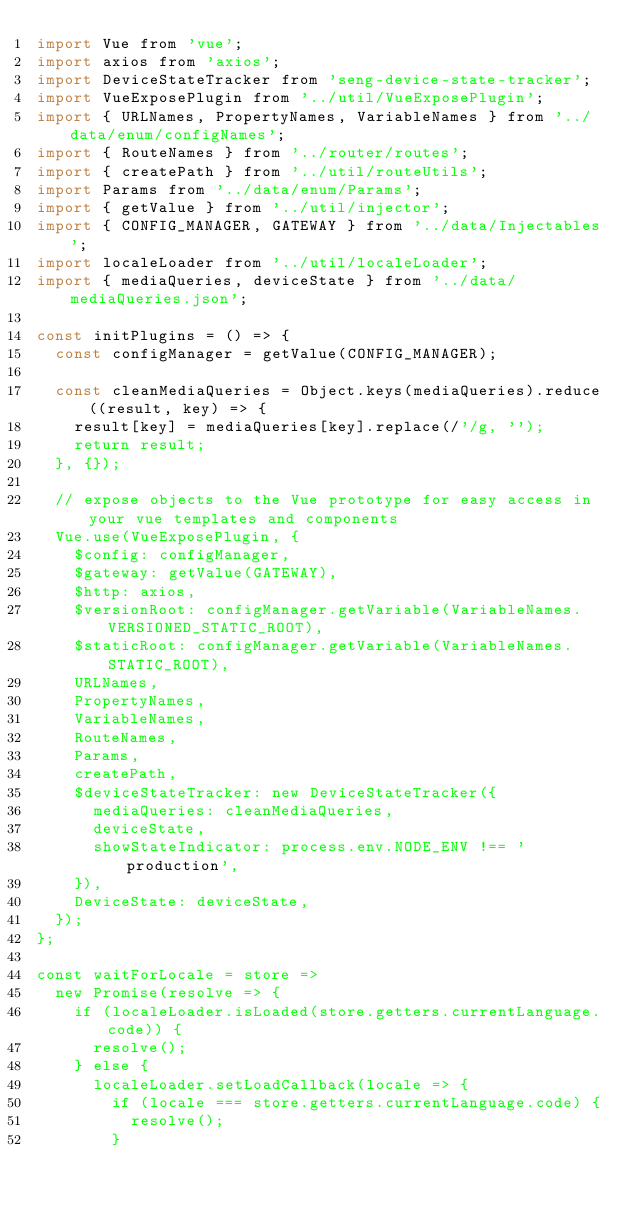Convert code to text. <code><loc_0><loc_0><loc_500><loc_500><_JavaScript_>import Vue from 'vue';
import axios from 'axios';
import DeviceStateTracker from 'seng-device-state-tracker';
import VueExposePlugin from '../util/VueExposePlugin';
import { URLNames, PropertyNames, VariableNames } from '../data/enum/configNames';
import { RouteNames } from '../router/routes';
import { createPath } from '../util/routeUtils';
import Params from '../data/enum/Params';
import { getValue } from '../util/injector';
import { CONFIG_MANAGER, GATEWAY } from '../data/Injectables';
import localeLoader from '../util/localeLoader';
import { mediaQueries, deviceState } from '../data/mediaQueries.json';

const initPlugins = () => {
  const configManager = getValue(CONFIG_MANAGER);

  const cleanMediaQueries = Object.keys(mediaQueries).reduce((result, key) => {
    result[key] = mediaQueries[key].replace(/'/g, '');
    return result;
  }, {});

  // expose objects to the Vue prototype for easy access in your vue templates and components
  Vue.use(VueExposePlugin, {
    $config: configManager,
    $gateway: getValue(GATEWAY),
    $http: axios,
    $versionRoot: configManager.getVariable(VariableNames.VERSIONED_STATIC_ROOT),
    $staticRoot: configManager.getVariable(VariableNames.STATIC_ROOT),
    URLNames,
    PropertyNames,
    VariableNames,
    RouteNames,
    Params,
    createPath,
    $deviceStateTracker: new DeviceStateTracker({
      mediaQueries: cleanMediaQueries,
      deviceState,
      showStateIndicator: process.env.NODE_ENV !== 'production',
    }),
    DeviceState: deviceState,
  });
};

const waitForLocale = store =>
  new Promise(resolve => {
    if (localeLoader.isLoaded(store.getters.currentLanguage.code)) {
      resolve();
    } else {
      localeLoader.setLoadCallback(locale => {
        if (locale === store.getters.currentLanguage.code) {
          resolve();
        }</code> 